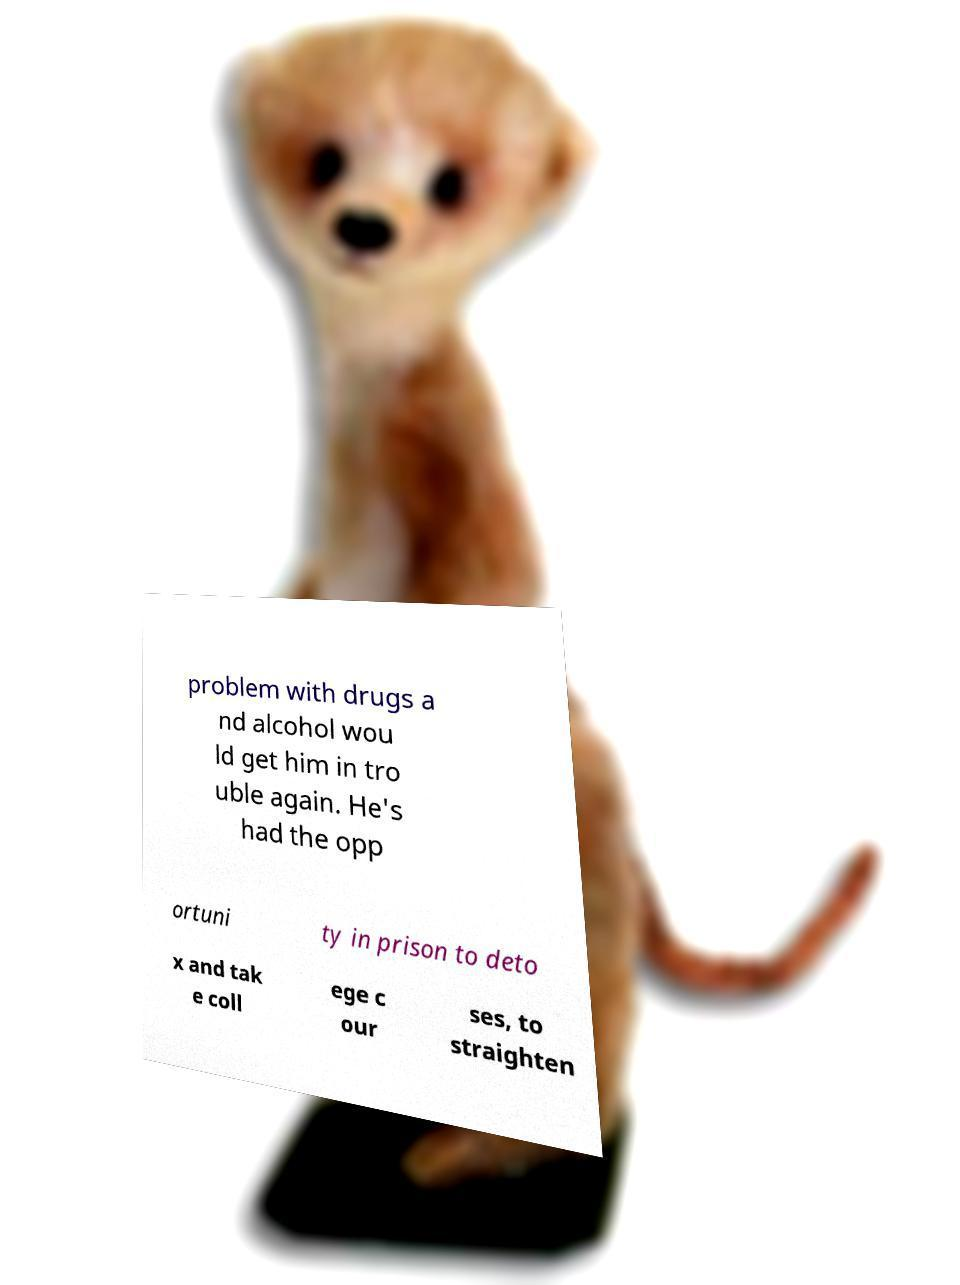There's text embedded in this image that I need extracted. Can you transcribe it verbatim? problem with drugs a nd alcohol wou ld get him in tro uble again. He's had the opp ortuni ty in prison to deto x and tak e coll ege c our ses, to straighten 